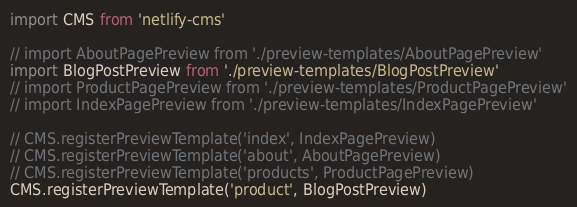Convert code to text. <code><loc_0><loc_0><loc_500><loc_500><_JavaScript_>import CMS from 'netlify-cms'

// import AboutPagePreview from './preview-templates/AboutPagePreview'
import BlogPostPreview from './preview-templates/BlogPostPreview'
// import ProductPagePreview from './preview-templates/ProductPagePreview'
// import IndexPagePreview from './preview-templates/IndexPagePreview'

// CMS.registerPreviewTemplate('index', IndexPagePreview)
// CMS.registerPreviewTemplate('about', AboutPagePreview)
// CMS.registerPreviewTemplate('products', ProductPagePreview)
CMS.registerPreviewTemplate('product', BlogPostPreview)
</code> 